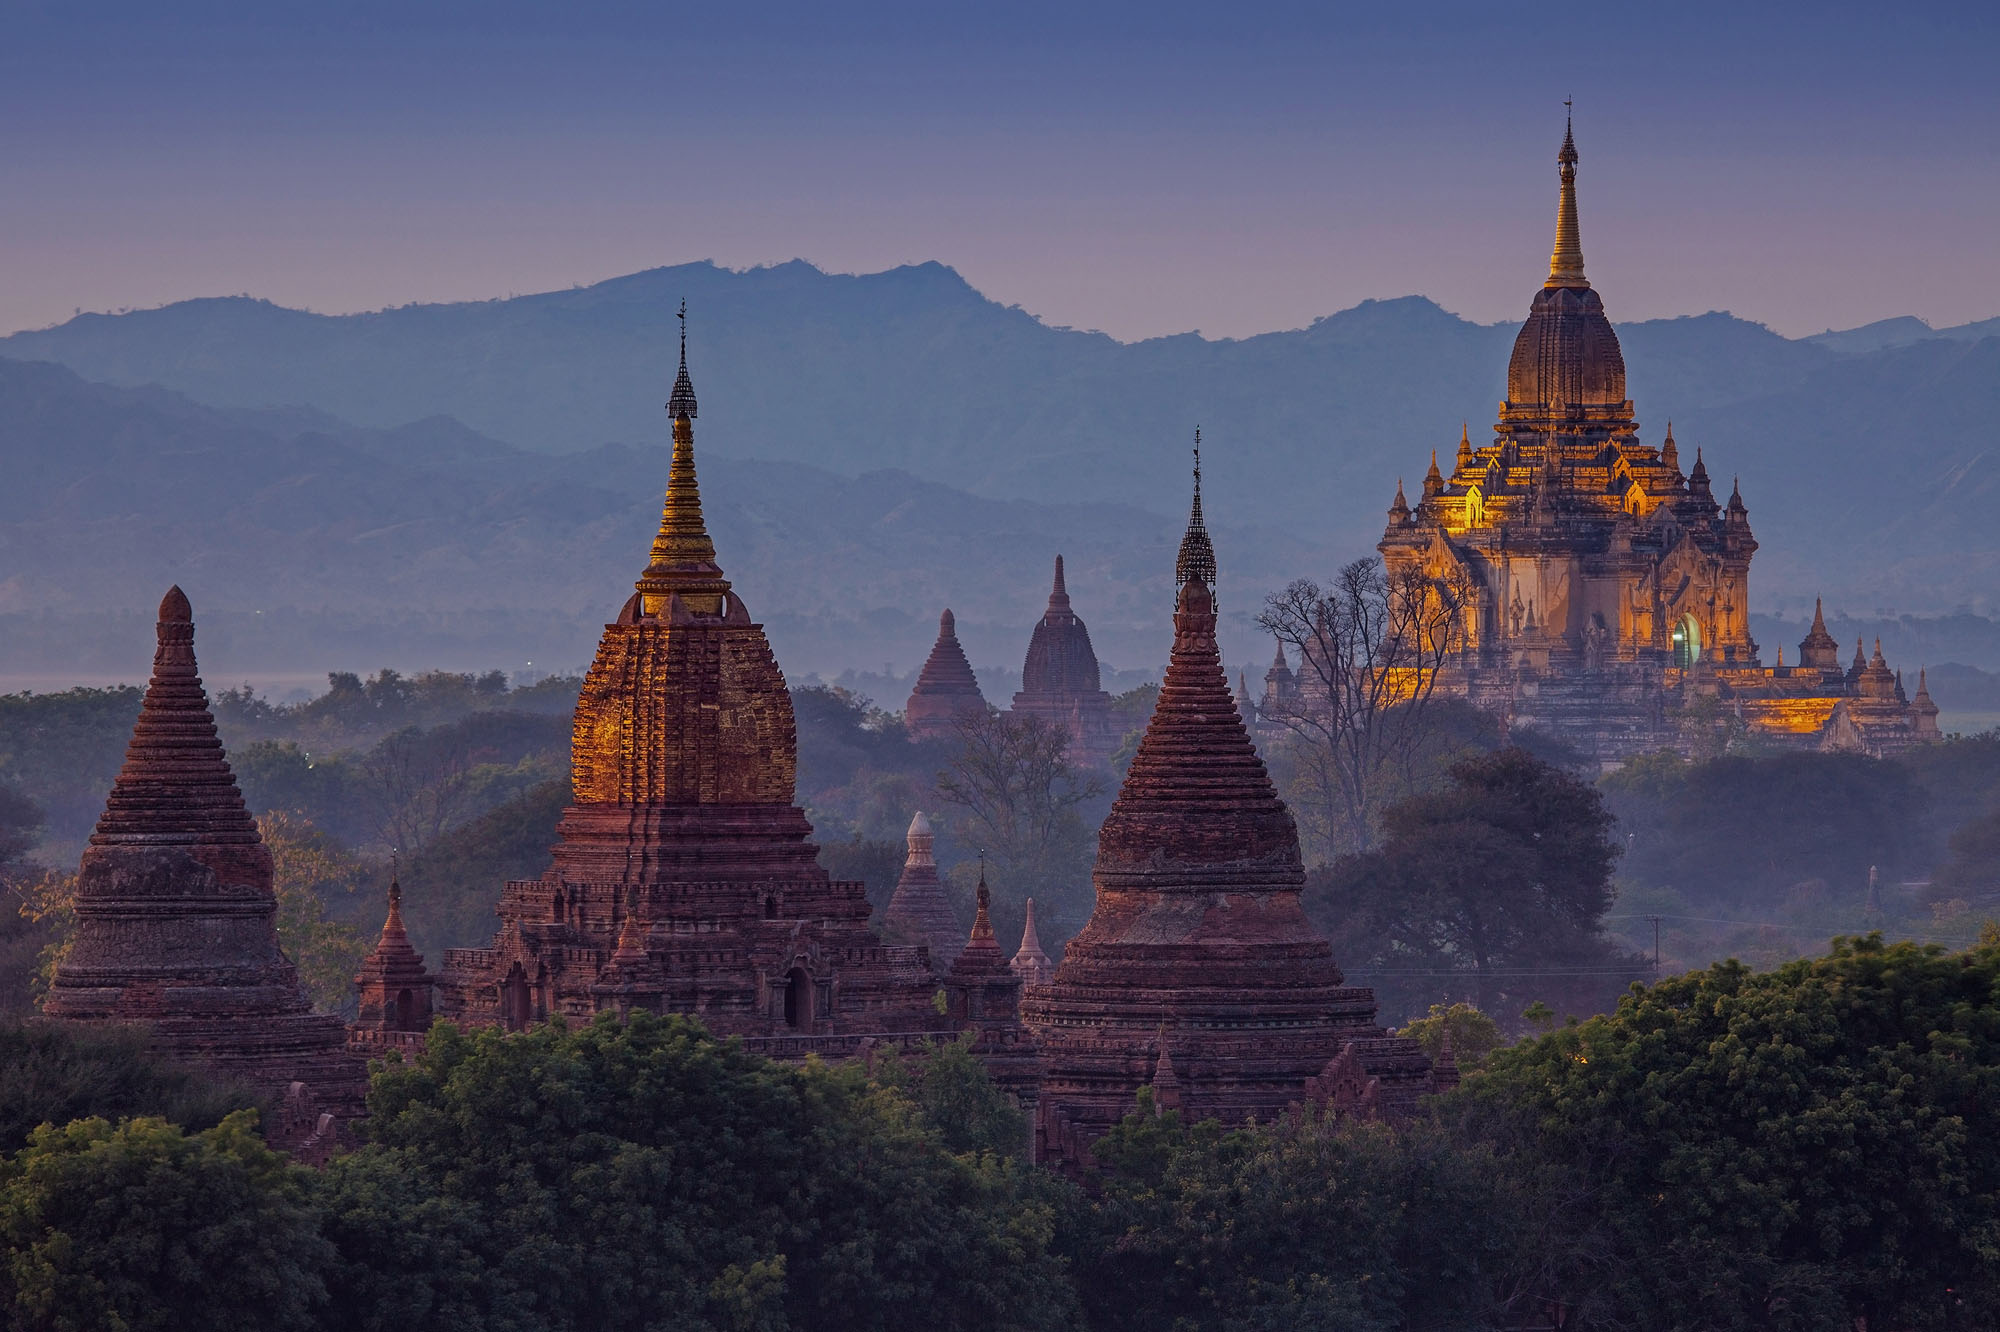What are the architectural styles visible in the Bagan temples? Bagan's temples showcase a range of architectural styles that reflect the evolution of Buddhist architecture over centuries. The early style includes simple stupas with a box-like structure. Middle period examples display more complex stupas with terraces. The late period brought taller, more ornate structures with intricate carvings and outer decorations. This diversity stands as a chronicle of the artistic and religious advancement over time. 